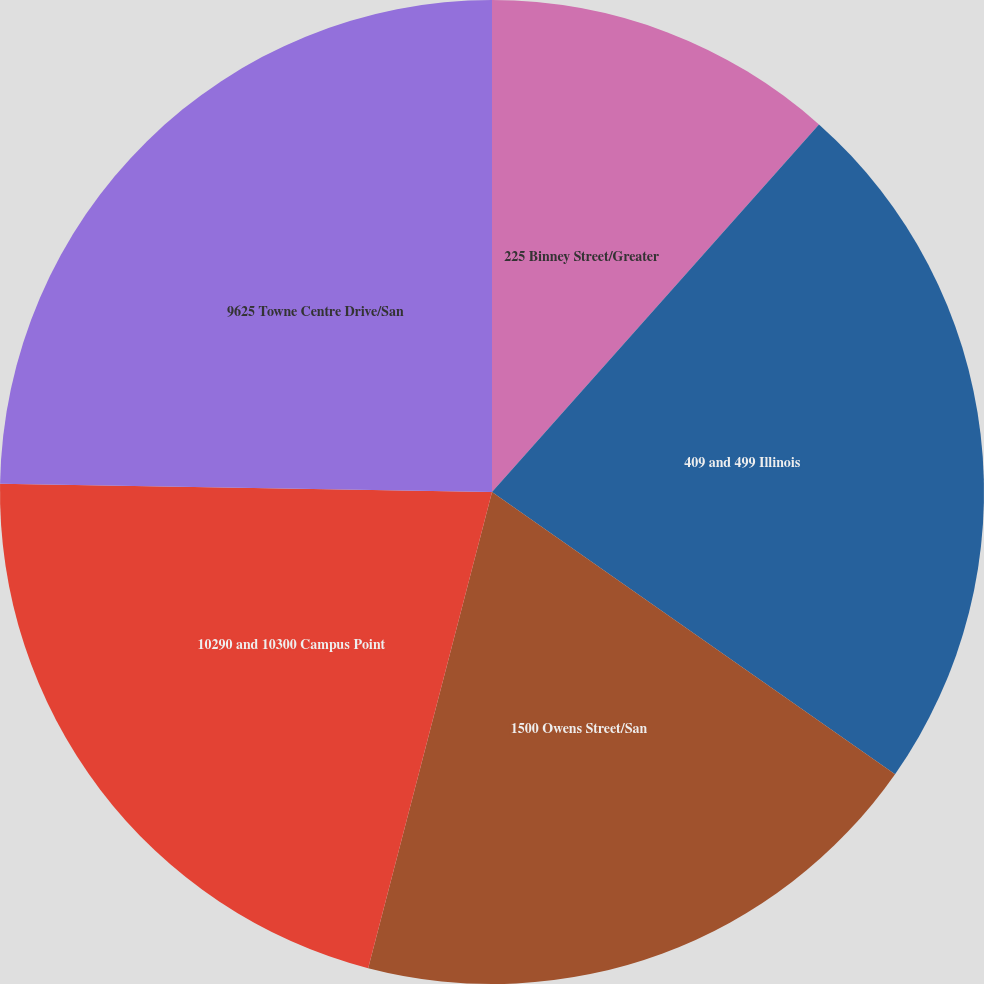Convert chart. <chart><loc_0><loc_0><loc_500><loc_500><pie_chart><fcel>225 Binney Street/Greater<fcel>409 and 499 Illinois<fcel>1500 Owens Street/San<fcel>10290 and 10300 Campus Point<fcel>9625 Towne Centre Drive/San<nl><fcel>11.57%<fcel>23.15%<fcel>19.33%<fcel>21.22%<fcel>24.73%<nl></chart> 